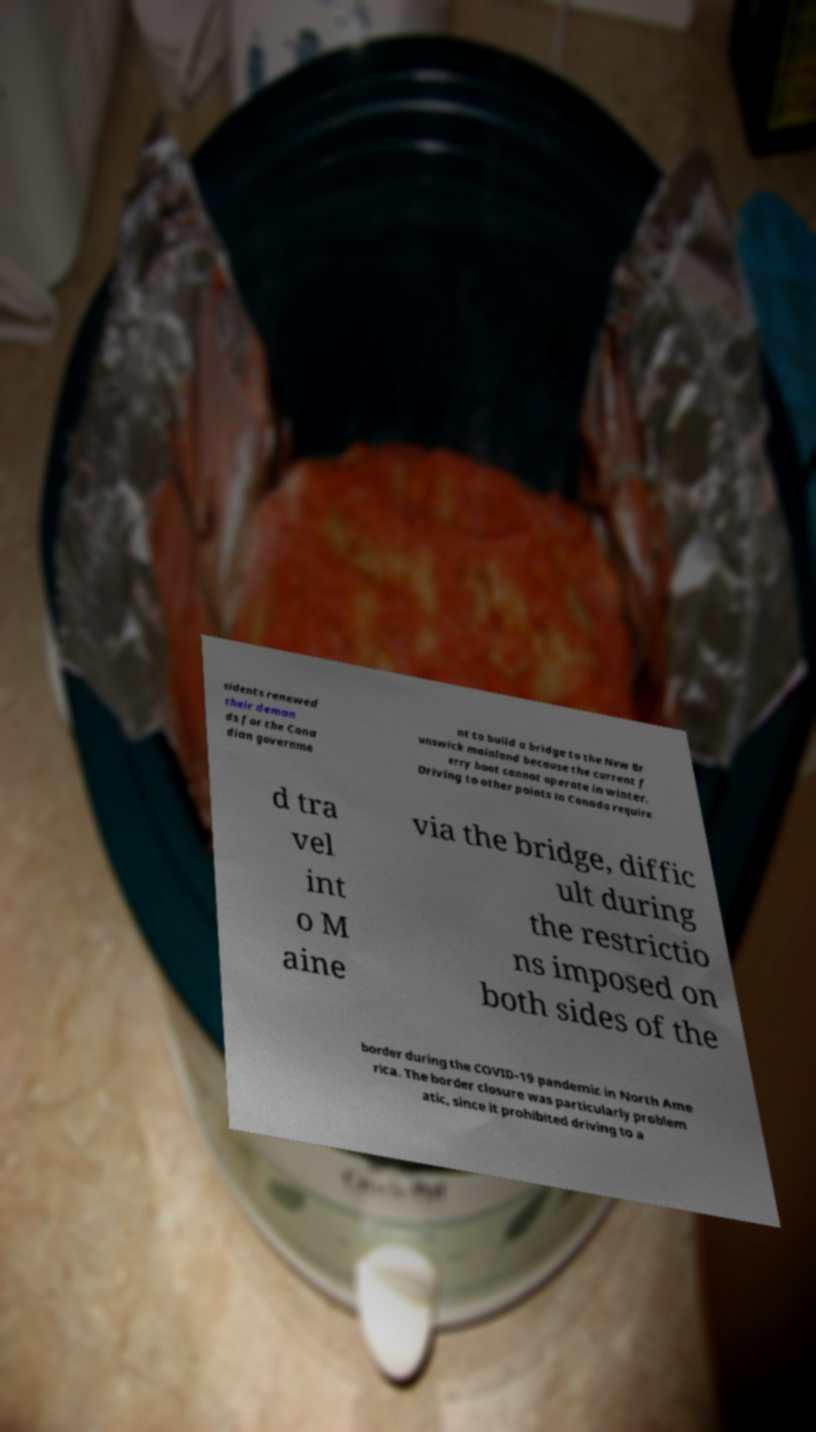Please read and relay the text visible in this image. What does it say? sidents renewed their deman ds for the Cana dian governme nt to build a bridge to the New Br unswick mainland because the current f erry boat cannot operate in winter. Driving to other points in Canada require d tra vel int o M aine via the bridge, diffic ult during the restrictio ns imposed on both sides of the border during the COVID-19 pandemic in North Ame rica. The border closure was particularly problem atic, since it prohibited driving to a 